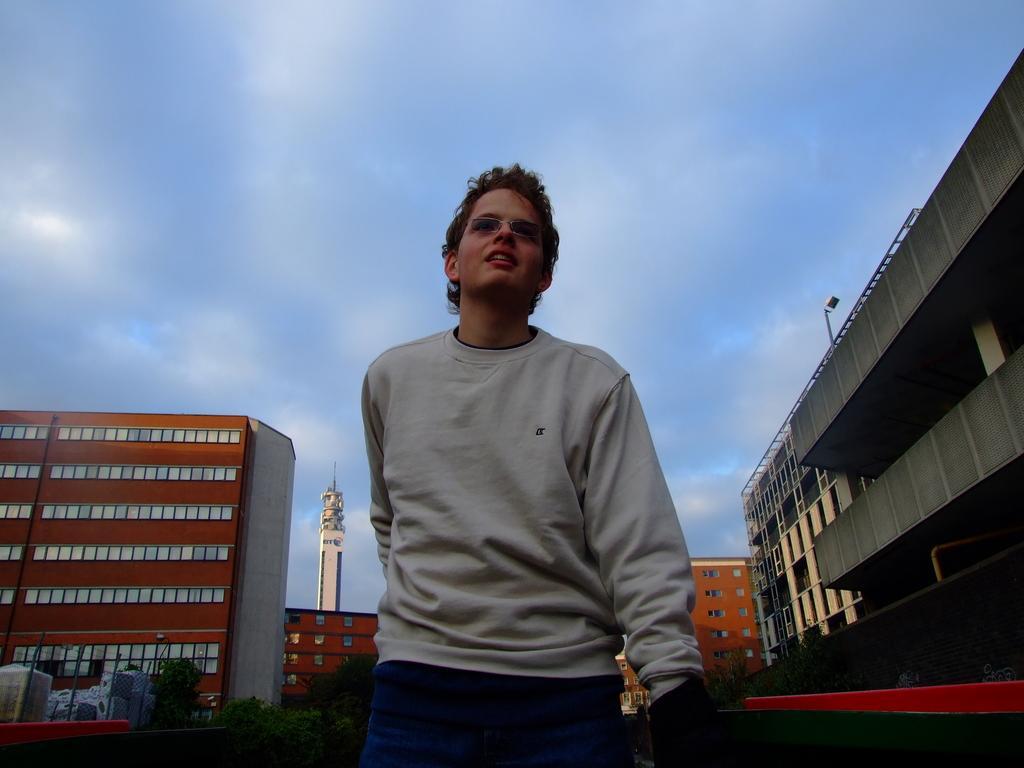How would you summarize this image in a sentence or two? In this picture we can see the sky, tower, buildings, trees, poles. We can see a man wearing spectacles. 